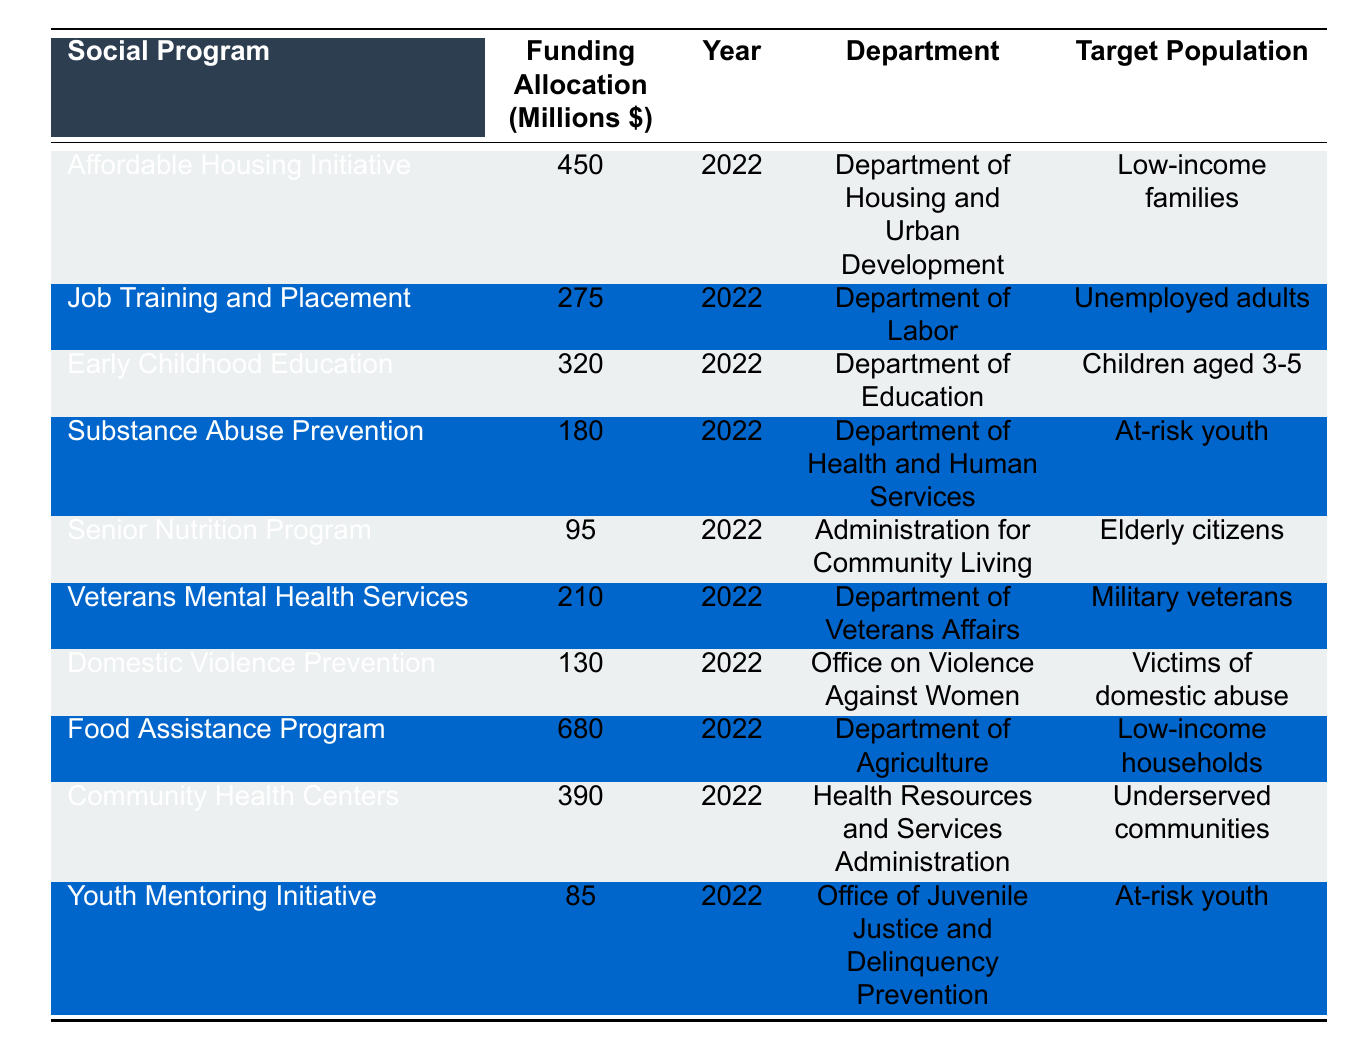What is the funding allocation for the Food Assistance Program? The funding allocation is found directly in the table under the respective program. The Food Assistance Program has a funding allocation of 680 million dollars.
Answer: 680 million dollars Which department oversees the Early Childhood Education program? The department responsible for the Early Childhood Education program is listed in the table. It is the Department of Education.
Answer: Department of Education How much funding was allocated to the Senior Nutrition Program? The funding for the Senior Nutrition Program is specified in the second column of the table, which shows it received 95 million dollars.
Answer: 95 million dollars Is the total funding for all programs greater than one billion dollars? To determine this, we need to add all funding allocations together. The total is \(450 + 275 + 320 + 180 + 95 + 210 + 130 + 680 + 390 + 85 = 2795\) million dollars, which is greater than one billion.
Answer: Yes What is the average funding allocation for all social programs listed? First, we calculate the total funding: 2795 million dollars. There are 10 programs listed, so the average is \(2795/10 = 279.5\) million dollars.
Answer: 279.5 million dollars Which social program has the lowest funding allocation, and what is that amount? By examining the funding allocations, the program with the lowest allocation is the Youth Mentoring Initiative with 85 million dollars.
Answer: Youth Mentoring Initiative, 85 million dollars What percentage of the total funding is allocated to the Food Assistance Program? The total funding is 2795 million dollars, and the Food Assistance Program is allocated 680 million dollars. The percentage is calculated as \((680/2795) * 100 ≈ 24.3\%\).
Answer: Approximately 24.3% How many social programs target at-risk youth? The table lists programs targeting at-risk youth, namely Substance Abuse Prevention and Youth Mentoring Initiative, so there are two programs.
Answer: 2 programs Is the total funding for programs aimed at low-income families greater than the funding for programs aimed at military veterans? The funding for low-income families includes the Affordable Housing Initiative (450 million) and Food Assistance Program (680 million) totaling \(450 + 680 = 1130\) million. For military veterans, the funding is 210 million. Since 1130 is greater than 210, the answer is yes.
Answer: Yes What is the difference in funding allocation between the Job Training and Placement program and the Substance Abuse Prevention program? The funding for Job Training and Placement is 275 million, and for Substance Abuse Prevention, it is 180 million. The difference is \(275 - 180 = 95\) million dollars.
Answer: 95 million dollars 